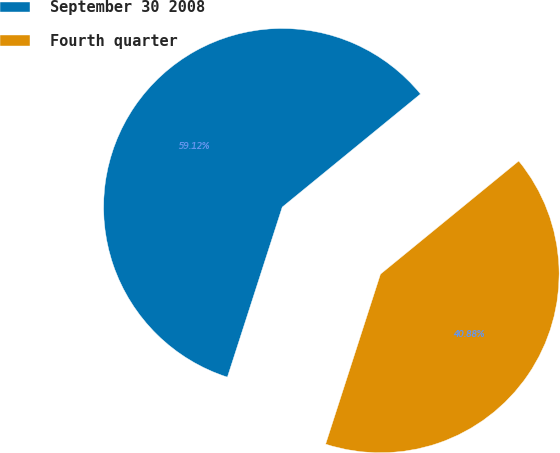Convert chart to OTSL. <chart><loc_0><loc_0><loc_500><loc_500><pie_chart><fcel>September 30 2008<fcel>Fourth quarter<nl><fcel>59.12%<fcel>40.88%<nl></chart> 